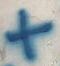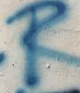Transcribe the words shown in these images in order, separated by a semicolon. +; R 